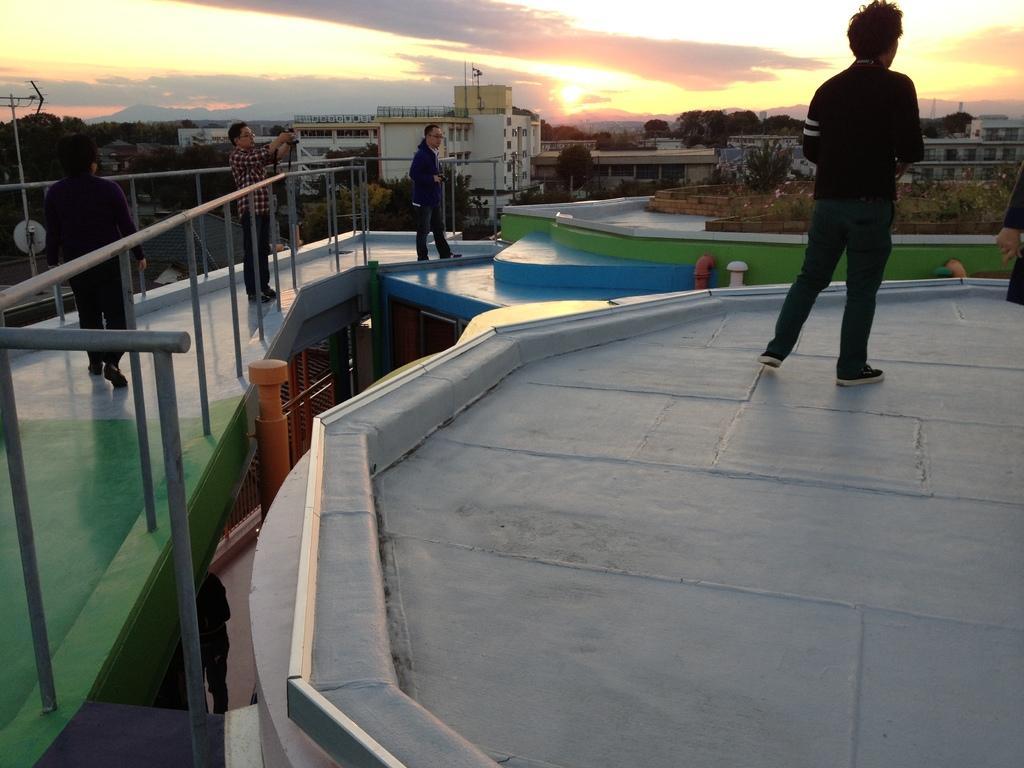In one or two sentences, can you explain what this image depicts? This is an outside view. On the right side there is a man standing on the floor facing towards the back side and I can see another person's hand. On the left side there is a person walking and two persons are standing. One man is holding an object in the hands and there is a railing. In the background there are many buildings and trees. At the top of the image I can see the sky. 